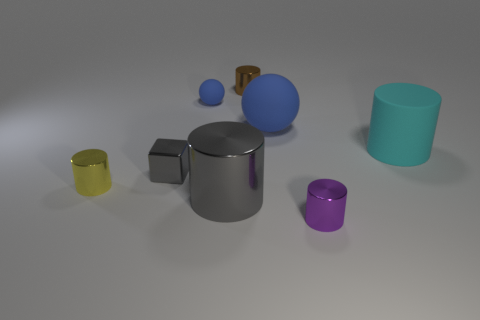Are there any brown metallic objects right of the tiny yellow cylinder?
Your answer should be compact. Yes. There is a matte ball that is the same size as the block; what is its color?
Provide a short and direct response. Blue. What number of small cubes have the same material as the big gray cylinder?
Your answer should be very brief. 1. What number of other things are there of the same size as the purple object?
Give a very brief answer. 4. Are there any blue matte objects that have the same size as the gray block?
Provide a succinct answer. Yes. There is a large thing in front of the small block; is its color the same as the tiny metallic block?
Offer a very short reply. Yes. How many objects are small brown cylinders or shiny things?
Offer a very short reply. 5. There is a cylinder that is right of the purple thing; is its size the same as the large blue rubber object?
Ensure brevity in your answer.  Yes. How big is the matte object that is behind the cyan thing and to the right of the gray cylinder?
Your response must be concise. Large. How many other things are there of the same shape as the small blue thing?
Provide a succinct answer. 1. 